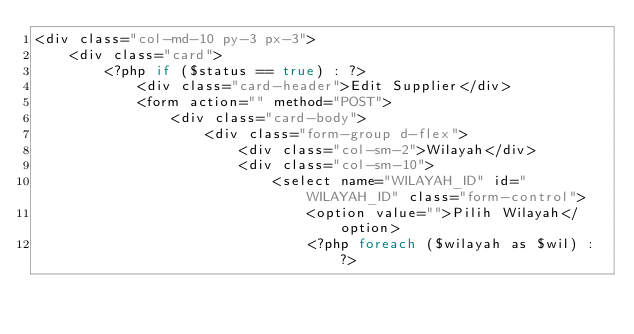Convert code to text. <code><loc_0><loc_0><loc_500><loc_500><_PHP_><div class="col-md-10 py-3 px-3">
    <div class="card">
        <?php if ($status == true) : ?>
            <div class="card-header">Edit Supplier</div>
            <form action="" method="POST">
                <div class="card-body">
                    <div class="form-group d-flex">
                        <div class="col-sm-2">Wilayah</div>
                        <div class="col-sm-10">
                            <select name="WILAYAH_ID" id="WILAYAH_ID" class="form-control">
                                <option value="">Pilih Wilayah</option>
                                <?php foreach ($wilayah as $wil) : ?></code> 